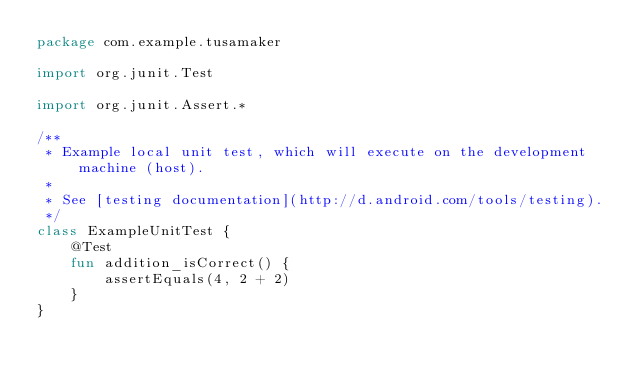Convert code to text. <code><loc_0><loc_0><loc_500><loc_500><_Kotlin_>package com.example.tusamaker

import org.junit.Test

import org.junit.Assert.*

/**
 * Example local unit test, which will execute on the development machine (host).
 *
 * See [testing documentation](http://d.android.com/tools/testing).
 */
class ExampleUnitTest {
    @Test
    fun addition_isCorrect() {
        assertEquals(4, 2 + 2)
    }
}
</code> 